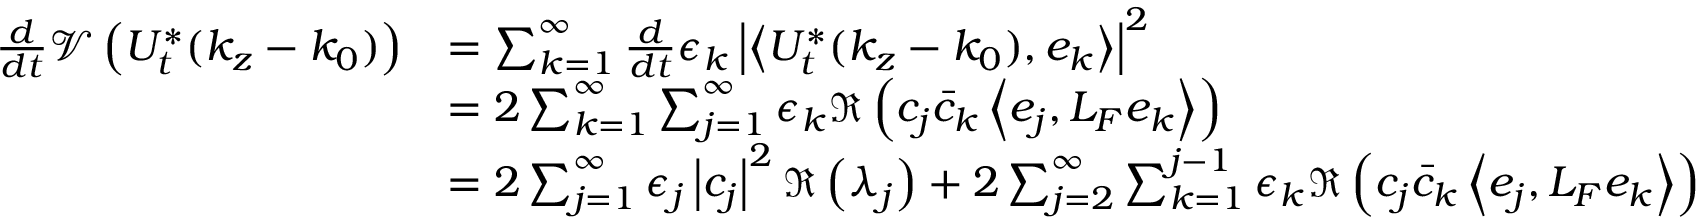<formula> <loc_0><loc_0><loc_500><loc_500>\begin{array} { r l } { \frac { d } { d t } \mathcal { V } \left ( U _ { t } ^ { * } ( k _ { z } - k _ { 0 } ) \right ) } & { = \sum _ { k = 1 } ^ { \infty } \frac { d } { d t } \epsilon _ { k } \left | \left \langle U _ { t } ^ { * } ( k _ { z } - k _ { 0 } ) , e _ { k } \right \rangle \right | ^ { 2 } } \\ & { = 2 \sum _ { k = 1 } ^ { \infty } \sum _ { j = 1 } ^ { \infty } \epsilon _ { k } \Re \left ( c _ { j } \bar { c } _ { k } \left \langle e _ { j } , L _ { F } e _ { k } \right \rangle \right ) } \\ & { = 2 \sum _ { j = 1 } ^ { \infty } \epsilon _ { j } \left | c _ { j } \right | ^ { 2 } \Re \left ( \lambda _ { j } \right ) + 2 \sum _ { j = 2 } ^ { \infty } \sum _ { k = 1 } ^ { j - 1 } \epsilon _ { k } \Re \left ( c _ { j } \bar { c } _ { k } \left \langle e _ { j } , L _ { F } e _ { k } \right \rangle \right ) } \end{array}</formula> 